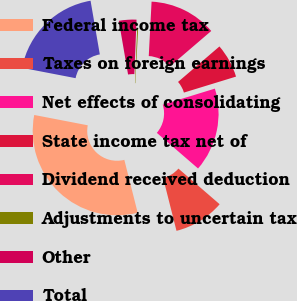Convert chart to OTSL. <chart><loc_0><loc_0><loc_500><loc_500><pie_chart><fcel>Federal income tax<fcel>Taxes on foreign earnings<fcel>Net effects of consolidating<fcel>State income tax net of<fcel>Dividend received deduction<fcel>Adjustments to uncertain tax<fcel>Other<fcel>Total<nl><fcel>31.97%<fcel>9.72%<fcel>16.08%<fcel>6.54%<fcel>12.9%<fcel>0.18%<fcel>3.36%<fcel>19.25%<nl></chart> 